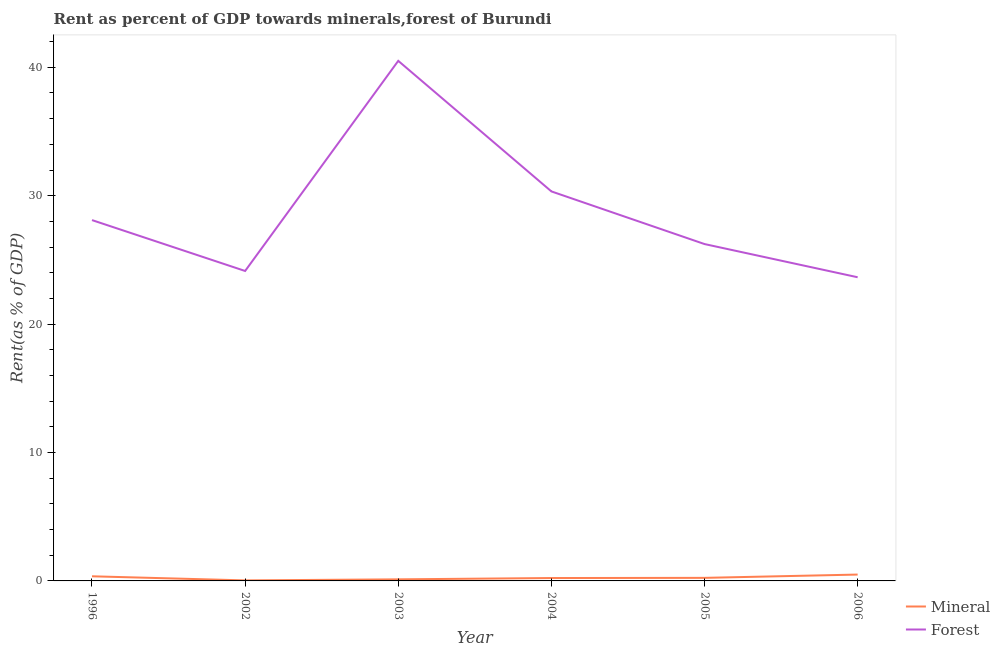Does the line corresponding to forest rent intersect with the line corresponding to mineral rent?
Ensure brevity in your answer.  No. Is the number of lines equal to the number of legend labels?
Give a very brief answer. Yes. What is the forest rent in 2003?
Your response must be concise. 40.5. Across all years, what is the maximum mineral rent?
Make the answer very short. 0.5. Across all years, what is the minimum mineral rent?
Give a very brief answer. 0.04. In which year was the mineral rent minimum?
Make the answer very short. 2002. What is the total mineral rent in the graph?
Provide a short and direct response. 1.48. What is the difference between the mineral rent in 2004 and that in 2005?
Ensure brevity in your answer.  -0.01. What is the difference between the mineral rent in 2006 and the forest rent in 2005?
Keep it short and to the point. -25.74. What is the average forest rent per year?
Give a very brief answer. 28.83. In the year 2002, what is the difference between the forest rent and mineral rent?
Ensure brevity in your answer.  24.1. What is the ratio of the mineral rent in 1996 to that in 2004?
Give a very brief answer. 1.6. What is the difference between the highest and the second highest forest rent?
Ensure brevity in your answer.  10.17. What is the difference between the highest and the lowest forest rent?
Give a very brief answer. 16.85. In how many years, is the mineral rent greater than the average mineral rent taken over all years?
Provide a short and direct response. 2. Is the sum of the forest rent in 2002 and 2004 greater than the maximum mineral rent across all years?
Offer a very short reply. Yes. Does the mineral rent monotonically increase over the years?
Provide a succinct answer. No. Is the forest rent strictly greater than the mineral rent over the years?
Offer a terse response. Yes. How many lines are there?
Your response must be concise. 2. What is the difference between two consecutive major ticks on the Y-axis?
Offer a terse response. 10. Where does the legend appear in the graph?
Provide a short and direct response. Bottom right. How many legend labels are there?
Your answer should be compact. 2. What is the title of the graph?
Provide a short and direct response. Rent as percent of GDP towards minerals,forest of Burundi. What is the label or title of the Y-axis?
Your answer should be compact. Rent(as % of GDP). What is the Rent(as % of GDP) in Mineral in 1996?
Provide a succinct answer. 0.36. What is the Rent(as % of GDP) of Forest in 1996?
Provide a succinct answer. 28.1. What is the Rent(as % of GDP) in Mineral in 2002?
Your response must be concise. 0.04. What is the Rent(as % of GDP) of Forest in 2002?
Your answer should be compact. 24.14. What is the Rent(as % of GDP) of Mineral in 2003?
Provide a succinct answer. 0.12. What is the Rent(as % of GDP) in Forest in 2003?
Provide a short and direct response. 40.5. What is the Rent(as % of GDP) of Mineral in 2004?
Keep it short and to the point. 0.22. What is the Rent(as % of GDP) in Forest in 2004?
Your answer should be compact. 30.33. What is the Rent(as % of GDP) of Mineral in 2005?
Make the answer very short. 0.24. What is the Rent(as % of GDP) in Forest in 2005?
Provide a short and direct response. 26.23. What is the Rent(as % of GDP) in Mineral in 2006?
Provide a succinct answer. 0.5. What is the Rent(as % of GDP) of Forest in 2006?
Your answer should be compact. 23.65. Across all years, what is the maximum Rent(as % of GDP) in Mineral?
Your response must be concise. 0.5. Across all years, what is the maximum Rent(as % of GDP) in Forest?
Give a very brief answer. 40.5. Across all years, what is the minimum Rent(as % of GDP) of Mineral?
Ensure brevity in your answer.  0.04. Across all years, what is the minimum Rent(as % of GDP) in Forest?
Offer a terse response. 23.65. What is the total Rent(as % of GDP) in Mineral in the graph?
Provide a short and direct response. 1.48. What is the total Rent(as % of GDP) in Forest in the graph?
Give a very brief answer. 172.96. What is the difference between the Rent(as % of GDP) in Mineral in 1996 and that in 2002?
Provide a short and direct response. 0.32. What is the difference between the Rent(as % of GDP) of Forest in 1996 and that in 2002?
Your answer should be very brief. 3.96. What is the difference between the Rent(as % of GDP) in Mineral in 1996 and that in 2003?
Keep it short and to the point. 0.24. What is the difference between the Rent(as % of GDP) in Forest in 1996 and that in 2003?
Your answer should be compact. -12.4. What is the difference between the Rent(as % of GDP) of Mineral in 1996 and that in 2004?
Provide a succinct answer. 0.14. What is the difference between the Rent(as % of GDP) in Forest in 1996 and that in 2004?
Ensure brevity in your answer.  -2.23. What is the difference between the Rent(as % of GDP) in Mineral in 1996 and that in 2005?
Your response must be concise. 0.12. What is the difference between the Rent(as % of GDP) in Forest in 1996 and that in 2005?
Your answer should be compact. 1.87. What is the difference between the Rent(as % of GDP) of Mineral in 1996 and that in 2006?
Make the answer very short. -0.14. What is the difference between the Rent(as % of GDP) in Forest in 1996 and that in 2006?
Keep it short and to the point. 4.45. What is the difference between the Rent(as % of GDP) in Mineral in 2002 and that in 2003?
Give a very brief answer. -0.08. What is the difference between the Rent(as % of GDP) of Forest in 2002 and that in 2003?
Give a very brief answer. -16.36. What is the difference between the Rent(as % of GDP) of Mineral in 2002 and that in 2004?
Your answer should be very brief. -0.18. What is the difference between the Rent(as % of GDP) of Forest in 2002 and that in 2004?
Offer a terse response. -6.2. What is the difference between the Rent(as % of GDP) of Mineral in 2002 and that in 2005?
Offer a very short reply. -0.2. What is the difference between the Rent(as % of GDP) in Forest in 2002 and that in 2005?
Your answer should be very brief. -2.1. What is the difference between the Rent(as % of GDP) of Mineral in 2002 and that in 2006?
Provide a succinct answer. -0.46. What is the difference between the Rent(as % of GDP) in Forest in 2002 and that in 2006?
Provide a short and direct response. 0.49. What is the difference between the Rent(as % of GDP) of Mineral in 2003 and that in 2004?
Ensure brevity in your answer.  -0.1. What is the difference between the Rent(as % of GDP) in Forest in 2003 and that in 2004?
Give a very brief answer. 10.17. What is the difference between the Rent(as % of GDP) in Mineral in 2003 and that in 2005?
Ensure brevity in your answer.  -0.12. What is the difference between the Rent(as % of GDP) in Forest in 2003 and that in 2005?
Give a very brief answer. 14.27. What is the difference between the Rent(as % of GDP) in Mineral in 2003 and that in 2006?
Keep it short and to the point. -0.37. What is the difference between the Rent(as % of GDP) in Forest in 2003 and that in 2006?
Your answer should be compact. 16.85. What is the difference between the Rent(as % of GDP) of Mineral in 2004 and that in 2005?
Offer a terse response. -0.01. What is the difference between the Rent(as % of GDP) in Forest in 2004 and that in 2005?
Your answer should be very brief. 4.1. What is the difference between the Rent(as % of GDP) in Mineral in 2004 and that in 2006?
Your answer should be compact. -0.27. What is the difference between the Rent(as % of GDP) in Forest in 2004 and that in 2006?
Provide a short and direct response. 6.69. What is the difference between the Rent(as % of GDP) in Mineral in 2005 and that in 2006?
Provide a succinct answer. -0.26. What is the difference between the Rent(as % of GDP) in Forest in 2005 and that in 2006?
Your answer should be compact. 2.59. What is the difference between the Rent(as % of GDP) in Mineral in 1996 and the Rent(as % of GDP) in Forest in 2002?
Your answer should be very brief. -23.78. What is the difference between the Rent(as % of GDP) of Mineral in 1996 and the Rent(as % of GDP) of Forest in 2003?
Keep it short and to the point. -40.14. What is the difference between the Rent(as % of GDP) of Mineral in 1996 and the Rent(as % of GDP) of Forest in 2004?
Your response must be concise. -29.98. What is the difference between the Rent(as % of GDP) in Mineral in 1996 and the Rent(as % of GDP) in Forest in 2005?
Give a very brief answer. -25.87. What is the difference between the Rent(as % of GDP) of Mineral in 1996 and the Rent(as % of GDP) of Forest in 2006?
Offer a very short reply. -23.29. What is the difference between the Rent(as % of GDP) of Mineral in 2002 and the Rent(as % of GDP) of Forest in 2003?
Ensure brevity in your answer.  -40.46. What is the difference between the Rent(as % of GDP) of Mineral in 2002 and the Rent(as % of GDP) of Forest in 2004?
Keep it short and to the point. -30.29. What is the difference between the Rent(as % of GDP) of Mineral in 2002 and the Rent(as % of GDP) of Forest in 2005?
Provide a succinct answer. -26.19. What is the difference between the Rent(as % of GDP) of Mineral in 2002 and the Rent(as % of GDP) of Forest in 2006?
Provide a succinct answer. -23.61. What is the difference between the Rent(as % of GDP) in Mineral in 2003 and the Rent(as % of GDP) in Forest in 2004?
Keep it short and to the point. -30.21. What is the difference between the Rent(as % of GDP) of Mineral in 2003 and the Rent(as % of GDP) of Forest in 2005?
Make the answer very short. -26.11. What is the difference between the Rent(as % of GDP) in Mineral in 2003 and the Rent(as % of GDP) in Forest in 2006?
Ensure brevity in your answer.  -23.53. What is the difference between the Rent(as % of GDP) in Mineral in 2004 and the Rent(as % of GDP) in Forest in 2005?
Your answer should be very brief. -26.01. What is the difference between the Rent(as % of GDP) of Mineral in 2004 and the Rent(as % of GDP) of Forest in 2006?
Provide a short and direct response. -23.42. What is the difference between the Rent(as % of GDP) in Mineral in 2005 and the Rent(as % of GDP) in Forest in 2006?
Provide a succinct answer. -23.41. What is the average Rent(as % of GDP) in Mineral per year?
Your answer should be compact. 0.25. What is the average Rent(as % of GDP) in Forest per year?
Your response must be concise. 28.83. In the year 1996, what is the difference between the Rent(as % of GDP) of Mineral and Rent(as % of GDP) of Forest?
Offer a terse response. -27.74. In the year 2002, what is the difference between the Rent(as % of GDP) in Mineral and Rent(as % of GDP) in Forest?
Your response must be concise. -24.1. In the year 2003, what is the difference between the Rent(as % of GDP) of Mineral and Rent(as % of GDP) of Forest?
Keep it short and to the point. -40.38. In the year 2004, what is the difference between the Rent(as % of GDP) in Mineral and Rent(as % of GDP) in Forest?
Provide a succinct answer. -30.11. In the year 2005, what is the difference between the Rent(as % of GDP) in Mineral and Rent(as % of GDP) in Forest?
Make the answer very short. -26. In the year 2006, what is the difference between the Rent(as % of GDP) in Mineral and Rent(as % of GDP) in Forest?
Your answer should be very brief. -23.15. What is the ratio of the Rent(as % of GDP) in Mineral in 1996 to that in 2002?
Offer a very short reply. 8.83. What is the ratio of the Rent(as % of GDP) in Forest in 1996 to that in 2002?
Provide a succinct answer. 1.16. What is the ratio of the Rent(as % of GDP) of Mineral in 1996 to that in 2003?
Keep it short and to the point. 2.92. What is the ratio of the Rent(as % of GDP) in Forest in 1996 to that in 2003?
Your answer should be very brief. 0.69. What is the ratio of the Rent(as % of GDP) of Mineral in 1996 to that in 2004?
Your answer should be compact. 1.6. What is the ratio of the Rent(as % of GDP) of Forest in 1996 to that in 2004?
Offer a very short reply. 0.93. What is the ratio of the Rent(as % of GDP) of Mineral in 1996 to that in 2005?
Offer a terse response. 1.51. What is the ratio of the Rent(as % of GDP) in Forest in 1996 to that in 2005?
Your answer should be very brief. 1.07. What is the ratio of the Rent(as % of GDP) of Mineral in 1996 to that in 2006?
Provide a short and direct response. 0.73. What is the ratio of the Rent(as % of GDP) of Forest in 1996 to that in 2006?
Offer a very short reply. 1.19. What is the ratio of the Rent(as % of GDP) in Mineral in 2002 to that in 2003?
Offer a very short reply. 0.33. What is the ratio of the Rent(as % of GDP) in Forest in 2002 to that in 2003?
Your answer should be compact. 0.6. What is the ratio of the Rent(as % of GDP) in Mineral in 2002 to that in 2004?
Keep it short and to the point. 0.18. What is the ratio of the Rent(as % of GDP) in Forest in 2002 to that in 2004?
Provide a succinct answer. 0.8. What is the ratio of the Rent(as % of GDP) of Mineral in 2002 to that in 2005?
Your response must be concise. 0.17. What is the ratio of the Rent(as % of GDP) in Forest in 2002 to that in 2005?
Keep it short and to the point. 0.92. What is the ratio of the Rent(as % of GDP) of Mineral in 2002 to that in 2006?
Give a very brief answer. 0.08. What is the ratio of the Rent(as % of GDP) of Forest in 2002 to that in 2006?
Provide a succinct answer. 1.02. What is the ratio of the Rent(as % of GDP) of Mineral in 2003 to that in 2004?
Your answer should be very brief. 0.55. What is the ratio of the Rent(as % of GDP) in Forest in 2003 to that in 2004?
Your answer should be compact. 1.34. What is the ratio of the Rent(as % of GDP) of Mineral in 2003 to that in 2005?
Provide a succinct answer. 0.52. What is the ratio of the Rent(as % of GDP) of Forest in 2003 to that in 2005?
Offer a terse response. 1.54. What is the ratio of the Rent(as % of GDP) of Mineral in 2003 to that in 2006?
Provide a short and direct response. 0.25. What is the ratio of the Rent(as % of GDP) in Forest in 2003 to that in 2006?
Keep it short and to the point. 1.71. What is the ratio of the Rent(as % of GDP) in Mineral in 2004 to that in 2005?
Provide a short and direct response. 0.94. What is the ratio of the Rent(as % of GDP) in Forest in 2004 to that in 2005?
Your response must be concise. 1.16. What is the ratio of the Rent(as % of GDP) of Mineral in 2004 to that in 2006?
Provide a short and direct response. 0.45. What is the ratio of the Rent(as % of GDP) of Forest in 2004 to that in 2006?
Ensure brevity in your answer.  1.28. What is the ratio of the Rent(as % of GDP) of Mineral in 2005 to that in 2006?
Give a very brief answer. 0.48. What is the ratio of the Rent(as % of GDP) in Forest in 2005 to that in 2006?
Keep it short and to the point. 1.11. What is the difference between the highest and the second highest Rent(as % of GDP) of Mineral?
Provide a short and direct response. 0.14. What is the difference between the highest and the second highest Rent(as % of GDP) of Forest?
Your answer should be compact. 10.17. What is the difference between the highest and the lowest Rent(as % of GDP) of Mineral?
Provide a succinct answer. 0.46. What is the difference between the highest and the lowest Rent(as % of GDP) of Forest?
Give a very brief answer. 16.85. 